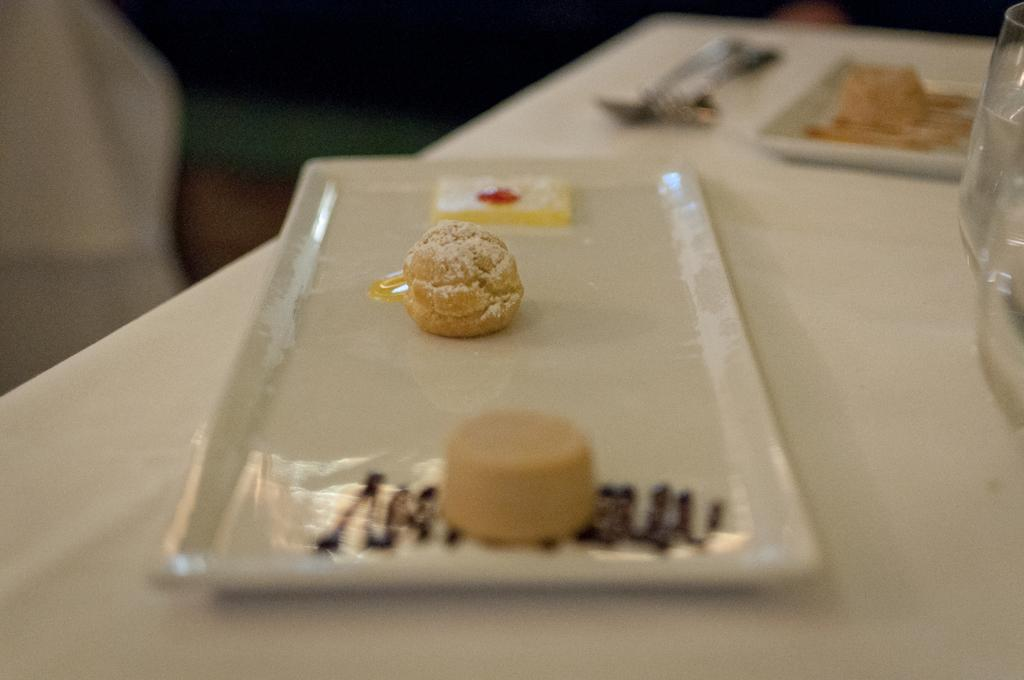What is on the white plate in the image? There are food items on the white plate in the image. Where is the white plate located? The white plate is on a table. What other items can be seen on the table? There are spoons and glasses on the table. Is there another plate on the table? Yes, there is another plate on the table. What language is spoken by the toe in the image? There is no toe present in the image, and therefore no language can be attributed to it. 